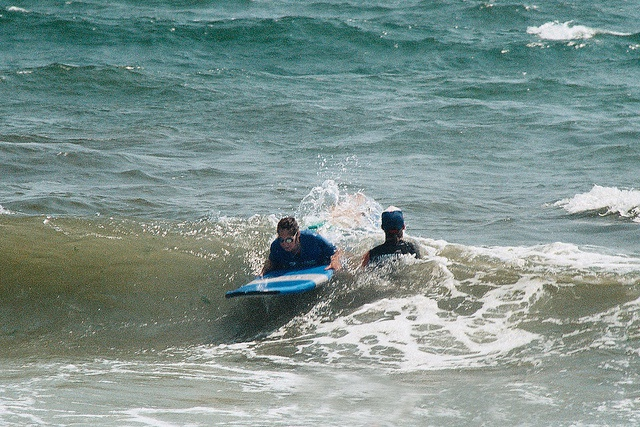Describe the objects in this image and their specific colors. I can see people in teal, black, navy, gray, and darkgray tones, people in teal, black, darkgray, gray, and lightgray tones, and surfboard in teal, lightgray, black, and navy tones in this image. 